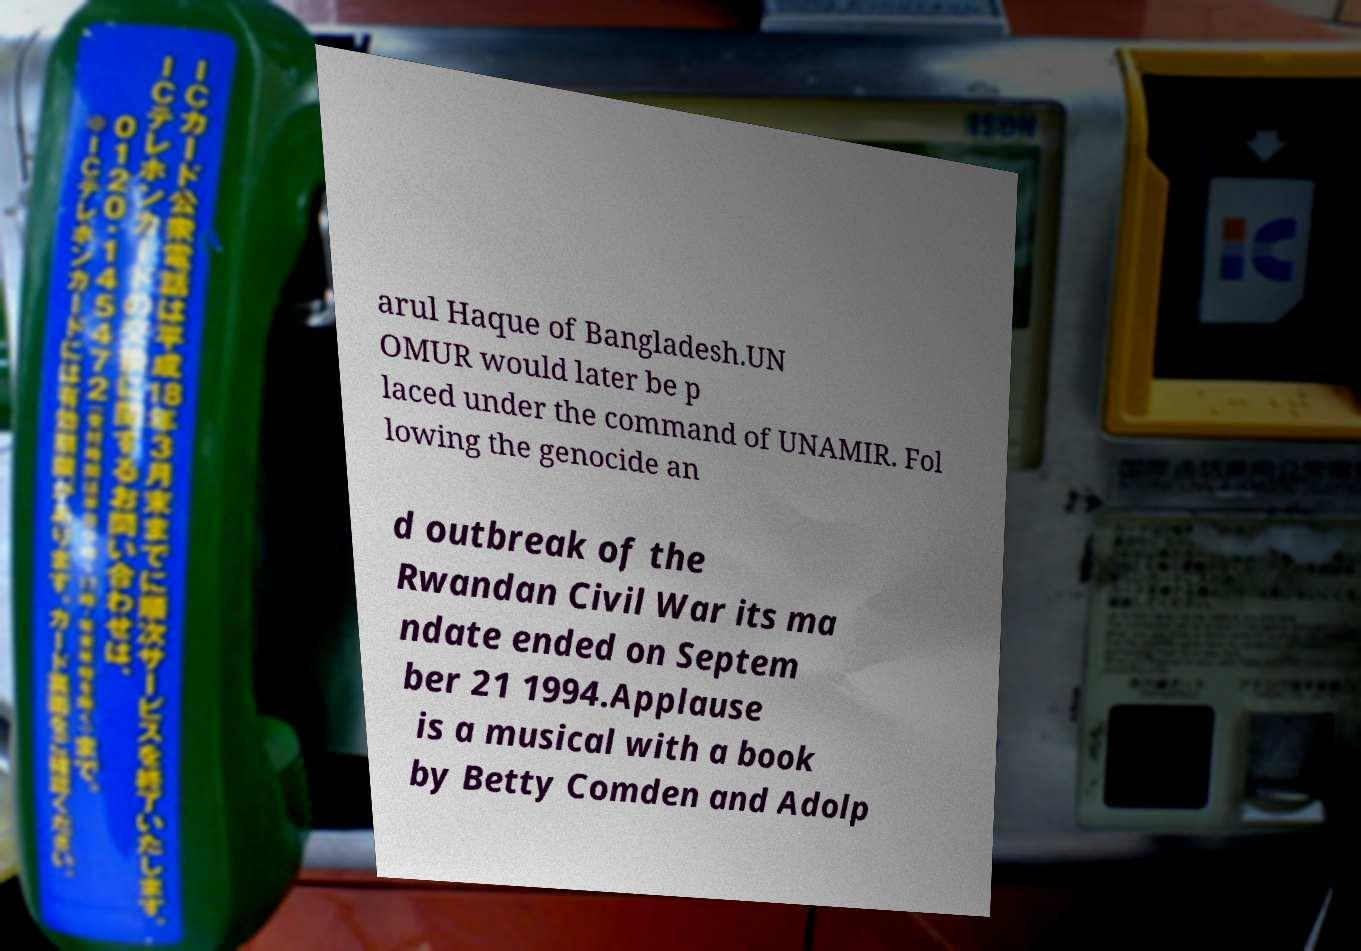There's text embedded in this image that I need extracted. Can you transcribe it verbatim? arul Haque of Bangladesh.UN OMUR would later be p laced under the command of UNAMIR. Fol lowing the genocide an d outbreak of the Rwandan Civil War its ma ndate ended on Septem ber 21 1994.Applause is a musical with a book by Betty Comden and Adolp 